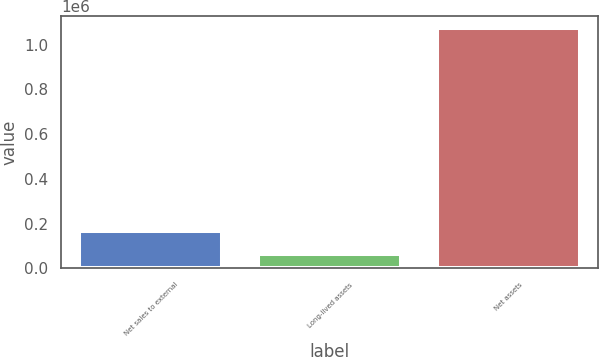<chart> <loc_0><loc_0><loc_500><loc_500><bar_chart><fcel>Net sales to external<fcel>Long-lived assets<fcel>Net assets<nl><fcel>166235<fcel>65280<fcel>1.07483e+06<nl></chart> 